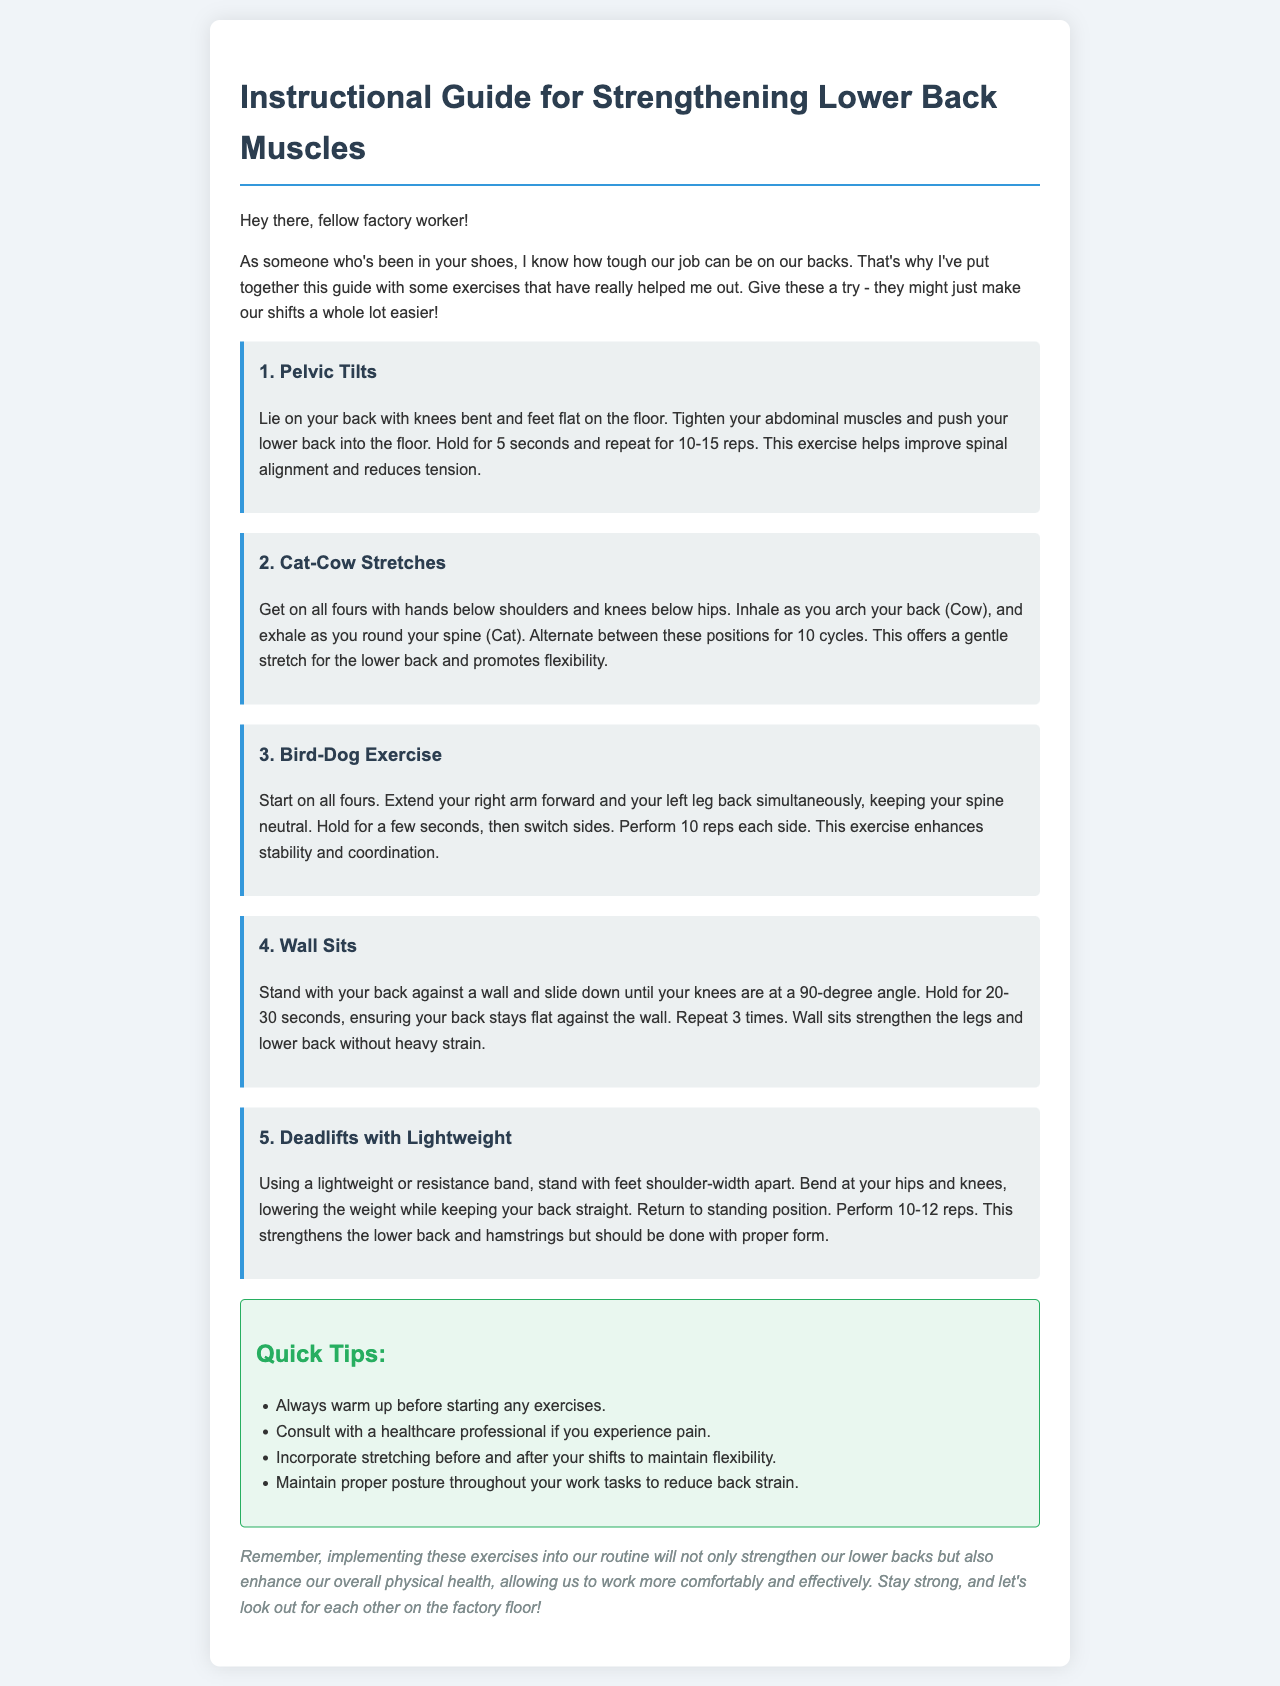What is the title of the guide? The title of the guide is found at the beginning of the document and outlines its purpose.
Answer: Instructional Guide for Strengthening Lower Back Muscles How many exercises are listed in the guide? The document lists a total of five exercises intended to strengthen the lower back.
Answer: 5 What should you do before starting any exercises? The guide emphasizes the importance of warming up before exercising to prevent injury.
Answer: warm up How long should you hold the Wall Sit exercise? The recommended duration for holding the Wall Sit exercise is mentioned in the exercise description.
Answer: 20-30 seconds Which exercise involves getting on all fours? The document describes multiple exercises, but one explicitly mentions starting on all fours.
Answer: Cat-Cow Stretches What is a key benefit of the Bird-Dog Exercise? The document highlights the enhancement of stability and coordination as a benefit of this exercise.
Answer: stability and coordination How many repetitions are suggested for the Bird-Dog Exercise? The number of repetitions for this exercise is specified in the description to help guide practice.
Answer: 10 reps each side What is advised to maintain flexibility according to the Quick Tips? The Quick Tips section offers advice on maintaining flexibility, which includes specific actions.
Answer: stretching before and after shifts What type of professional should you consult if you experience pain? The guide recommends seeking advice from a specific type of professional regarding pain.
Answer: healthcare professional 